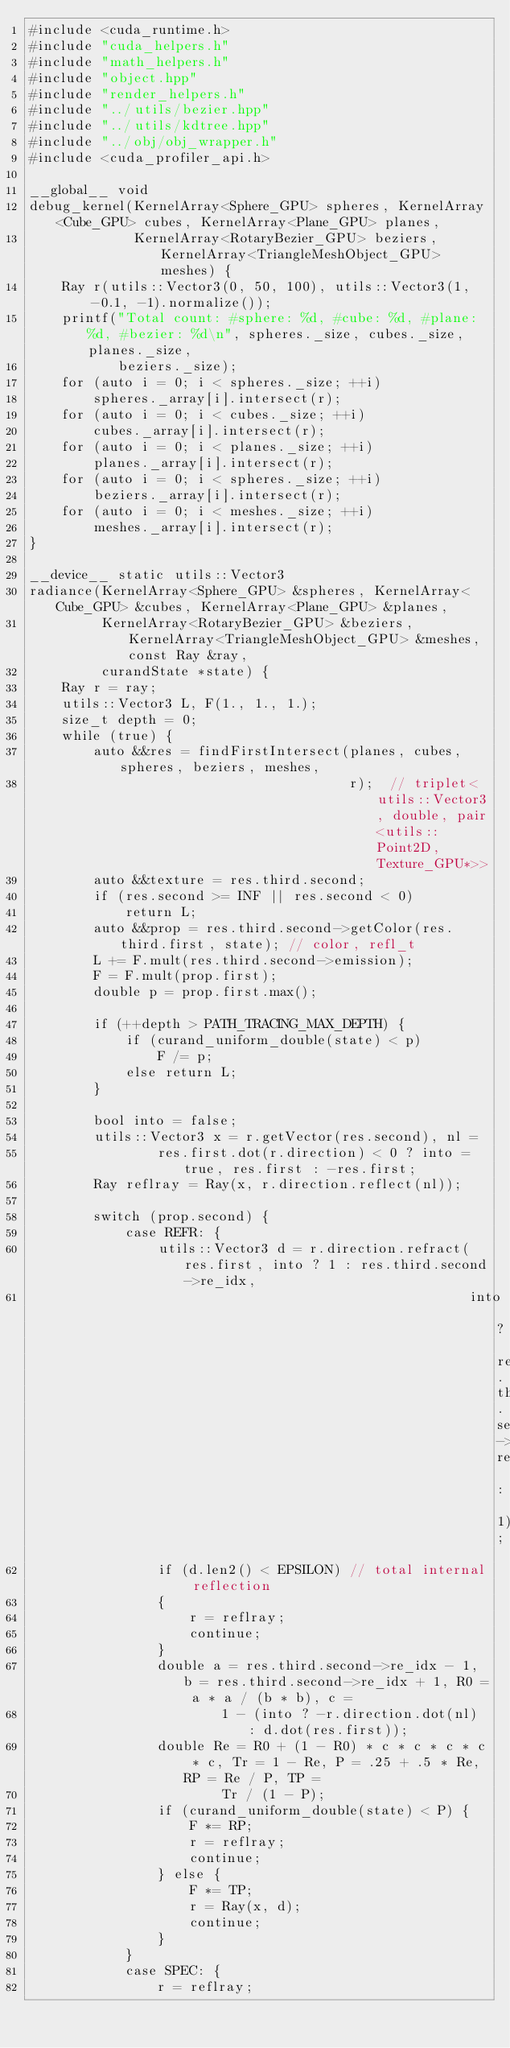Convert code to text. <code><loc_0><loc_0><loc_500><loc_500><_Cuda_>#include <cuda_runtime.h>
#include "cuda_helpers.h"
#include "math_helpers.h"
#include "object.hpp"
#include "render_helpers.h"
#include "../utils/bezier.hpp"
#include "../utils/kdtree.hpp"
#include "../obj/obj_wrapper.h"
#include <cuda_profiler_api.h>

__global__ void
debug_kernel(KernelArray<Sphere_GPU> spheres, KernelArray<Cube_GPU> cubes, KernelArray<Plane_GPU> planes,
             KernelArray<RotaryBezier_GPU> beziers, KernelArray<TriangleMeshObject_GPU> meshes) {
    Ray r(utils::Vector3(0, 50, 100), utils::Vector3(1, -0.1, -1).normalize());
    printf("Total count: #sphere: %d, #cube: %d, #plane: %d, #bezier: %d\n", spheres._size, cubes._size, planes._size,
           beziers._size);
    for (auto i = 0; i < spheres._size; ++i)
        spheres._array[i].intersect(r);
    for (auto i = 0; i < cubes._size; ++i)
        cubes._array[i].intersect(r);
    for (auto i = 0; i < planes._size; ++i)
        planes._array[i].intersect(r);
    for (auto i = 0; i < spheres._size; ++i)
        beziers._array[i].intersect(r);
    for (auto i = 0; i < meshes._size; ++i)
        meshes._array[i].intersect(r);
}

__device__ static utils::Vector3
radiance(KernelArray<Sphere_GPU> &spheres, KernelArray<Cube_GPU> &cubes, KernelArray<Plane_GPU> &planes,
         KernelArray<RotaryBezier_GPU> &beziers, KernelArray<TriangleMeshObject_GPU> &meshes, const Ray &ray,
         curandState *state) {
    Ray r = ray;
    utils::Vector3 L, F(1., 1., 1.);
    size_t depth = 0;
    while (true) {
        auto &&res = findFirstIntersect(planes, cubes, spheres, beziers, meshes,
                                        r);  // triplet<utils::Vector3, double, pair<utils::Point2D, Texture_GPU*>>
        auto &&texture = res.third.second;
        if (res.second >= INF || res.second < 0)
            return L;
        auto &&prop = res.third.second->getColor(res.third.first, state); // color, refl_t
        L += F.mult(res.third.second->emission);
        F = F.mult(prop.first);
        double p = prop.first.max();
        
        if (++depth > PATH_TRACING_MAX_DEPTH) {
            if (curand_uniform_double(state) < p)
                F /= p;
            else return L;
        }

        bool into = false;
        utils::Vector3 x = r.getVector(res.second), nl =
                res.first.dot(r.direction) < 0 ? into = true, res.first : -res.first;
        Ray reflray = Ray(x, r.direction.reflect(nl));

        switch (prop.second) {
            case REFR: {
                utils::Vector3 d = r.direction.refract(res.first, into ? 1 : res.third.second->re_idx,
                                                       into ? res.third.second->re_idx : 1);
                if (d.len2() < EPSILON) // total internal reflection
                {
                    r = reflray;
                    continue;
                }
                double a = res.third.second->re_idx - 1, b = res.third.second->re_idx + 1, R0 = a * a / (b * b), c =
                        1 - (into ? -r.direction.dot(nl) : d.dot(res.first));
                double Re = R0 + (1 - R0) * c * c * c * c * c, Tr = 1 - Re, P = .25 + .5 * Re, RP = Re / P, TP =
                        Tr / (1 - P);
                if (curand_uniform_double(state) < P) {
                    F *= RP;
                    r = reflray;
                    continue;
                } else {
                    F *= TP;
                    r = Ray(x, d);
                    continue;
                }
            }
            case SPEC: {
                r = reflray;</code> 